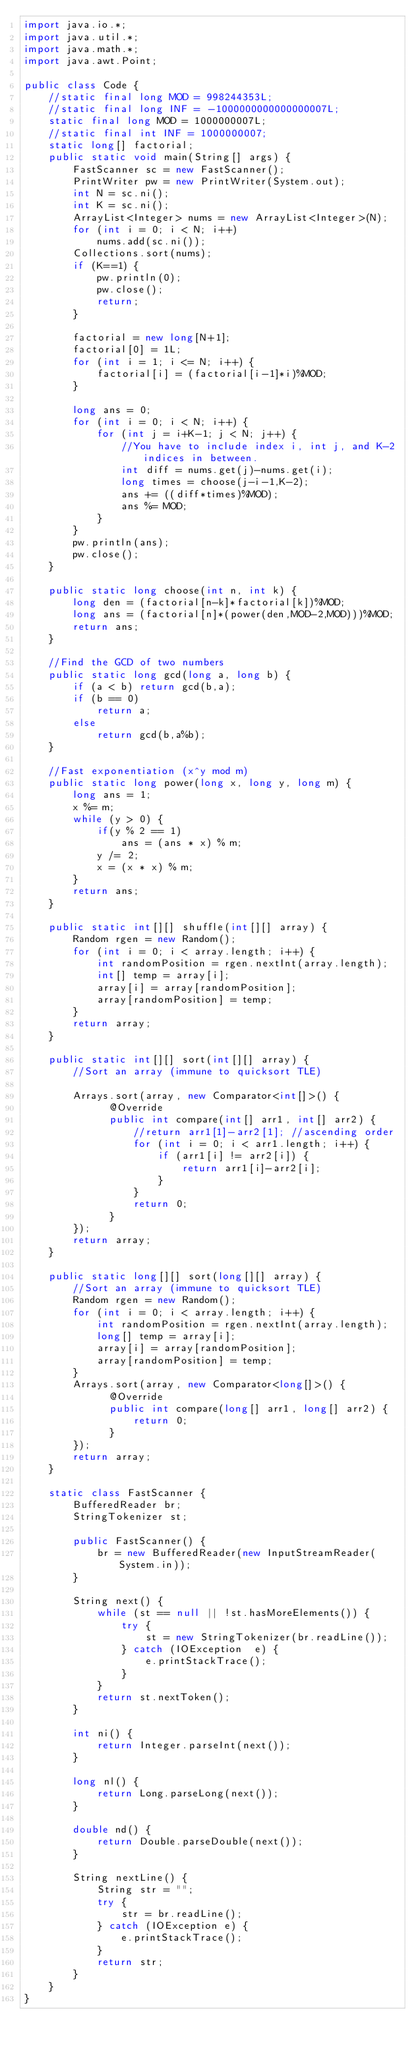Convert code to text. <code><loc_0><loc_0><loc_500><loc_500><_Java_>import java.io.*;
import java.util.*;
import java.math.*;
import java.awt.Point;
 
public class Code {
	//static final long MOD = 998244353L;
	//static final long INF = -1000000000000000007L;
	static final long MOD = 1000000007L;
	//static final int INF = 1000000007;
	static long[] factorial;
	public static void main(String[] args) {
		FastScanner sc = new FastScanner();
		PrintWriter pw = new PrintWriter(System.out);
		int N = sc.ni();
		int K = sc.ni();
		ArrayList<Integer> nums = new ArrayList<Integer>(N);
		for (int i = 0; i < N; i++)
			nums.add(sc.ni());
		Collections.sort(nums);
		if (K==1) {
			pw.println(0);
			pw.close();
			return;
		}
		
		factorial = new long[N+1];
		factorial[0] = 1L;
		for (int i = 1; i <= N; i++) {
			factorial[i] = (factorial[i-1]*i)%MOD;
		}
		
		long ans = 0;
		for (int i = 0; i < N; i++) {
			for (int j = i+K-1; j < N; j++) {
				//You have to include index i, int j, and K-2 indices in between.
				int diff = nums.get(j)-nums.get(i);
				long times = choose(j-i-1,K-2);
				ans += ((diff*times)%MOD);
				ans %= MOD;
			}
		}
		pw.println(ans);
		pw.close();
	}
	
	public static long choose(int n, int k) {
		long den = (factorial[n-k]*factorial[k])%MOD;
		long ans = (factorial[n]*(power(den,MOD-2,MOD)))%MOD;
		return ans;
	}
	
	//Find the GCD of two numbers
	public static long gcd(long a, long b) {
		if (a < b) return gcd(b,a);
		if (b == 0)
			return a;
		else
			return gcd(b,a%b);
	}
	
	//Fast exponentiation (x^y mod m)
	public static long power(long x, long y, long m) { 
		long ans = 1;
		x %= m;
		while (y > 0) { 
			if(y % 2 == 1) 
				ans = (ans * x) % m; 
			y /= 2;  
			x = (x * x) % m;
		} 
		return ans; 
	}
	
	public static int[][] shuffle(int[][] array) {
		Random rgen = new Random();
		for (int i = 0; i < array.length; i++) {
		    int randomPosition = rgen.nextInt(array.length);
		    int[] temp = array[i];
		    array[i] = array[randomPosition];
		    array[randomPosition] = temp;
		}
		return array;
	}
	
    public static int[][] sort(int[][] array) {
    	//Sort an array (immune to quicksort TLE)
 
		Arrays.sort(array, new Comparator<int[]>() {
			  @Override
        	  public int compare(int[] arr1, int[] arr2) {
				  //return arr1[1]-arr2[1]; //ascending order
				  for (int i = 0; i < arr1.length; i++) {
					  if (arr1[i] != arr2[i]) {
						  return arr1[i]-arr2[i];
					  }
				  }
				  return 0;
	          }
		});
		return array;
	}
    
    public static long[][] sort(long[][] array) {
    	//Sort an array (immune to quicksort TLE)
		Random rgen = new Random();
		for (int i = 0; i < array.length; i++) {
		    int randomPosition = rgen.nextInt(array.length);
		    long[] temp = array[i];
		    array[i] = array[randomPosition];
		    array[randomPosition] = temp;
		}
		Arrays.sort(array, new Comparator<long[]>() {
			  @Override
        	  public int compare(long[] arr1, long[] arr2) {
				  return 0;
	          }
		});
		return array;
	}
    
    static class FastScanner { 
        BufferedReader br; 
        StringTokenizer st; 
  
        public FastScanner() { 
            br = new BufferedReader(new InputStreamReader(System.in)); 
        } 
  
        String next() { 
            while (st == null || !st.hasMoreElements()) { 
                try { 
                    st = new StringTokenizer(br.readLine());
                } catch (IOException  e) { 
                    e.printStackTrace(); 
                } 
            } 
            return st.nextToken(); 
        } 
  
        int ni() { 
            return Integer.parseInt(next()); 
        } 
  
        long nl() { 
            return Long.parseLong(next()); 
        } 
  
        double nd() { 
            return Double.parseDouble(next()); 
        } 
  
        String nextLine() { 
            String str = ""; 
            try { 
                str = br.readLine(); 
            } catch (IOException e) {
                e.printStackTrace(); 
            } 
            return str;
        }
    }
}</code> 